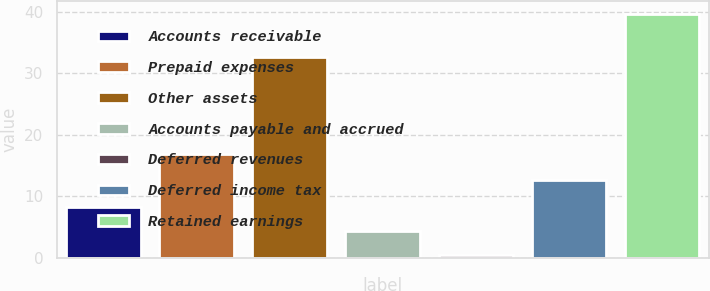Convert chart. <chart><loc_0><loc_0><loc_500><loc_500><bar_chart><fcel>Accounts receivable<fcel>Prepaid expenses<fcel>Other assets<fcel>Accounts payable and accrued<fcel>Deferred revenues<fcel>Deferred income tax<fcel>Retained earnings<nl><fcel>8.34<fcel>16.9<fcel>32.6<fcel>4.42<fcel>0.5<fcel>12.7<fcel>39.7<nl></chart> 